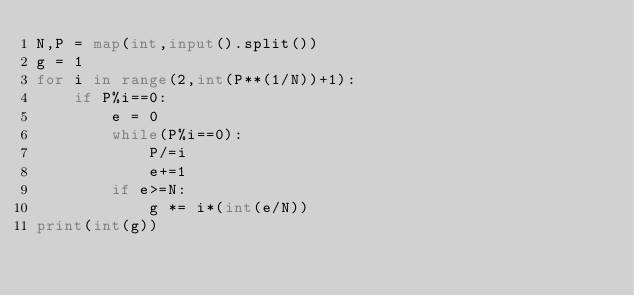<code> <loc_0><loc_0><loc_500><loc_500><_Python_>N,P = map(int,input().split())
g = 1
for i in range(2,int(P**(1/N))+1):
    if P%i==0:
        e = 0
        while(P%i==0):
            P/=i
            e+=1
        if e>=N:
            g *= i*(int(e/N))
print(int(g))</code> 